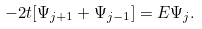Convert formula to latex. <formula><loc_0><loc_0><loc_500><loc_500>- 2 t [ \Psi _ { j + 1 } + \Psi _ { j - 1 } ] = E \Psi _ { j } .</formula> 